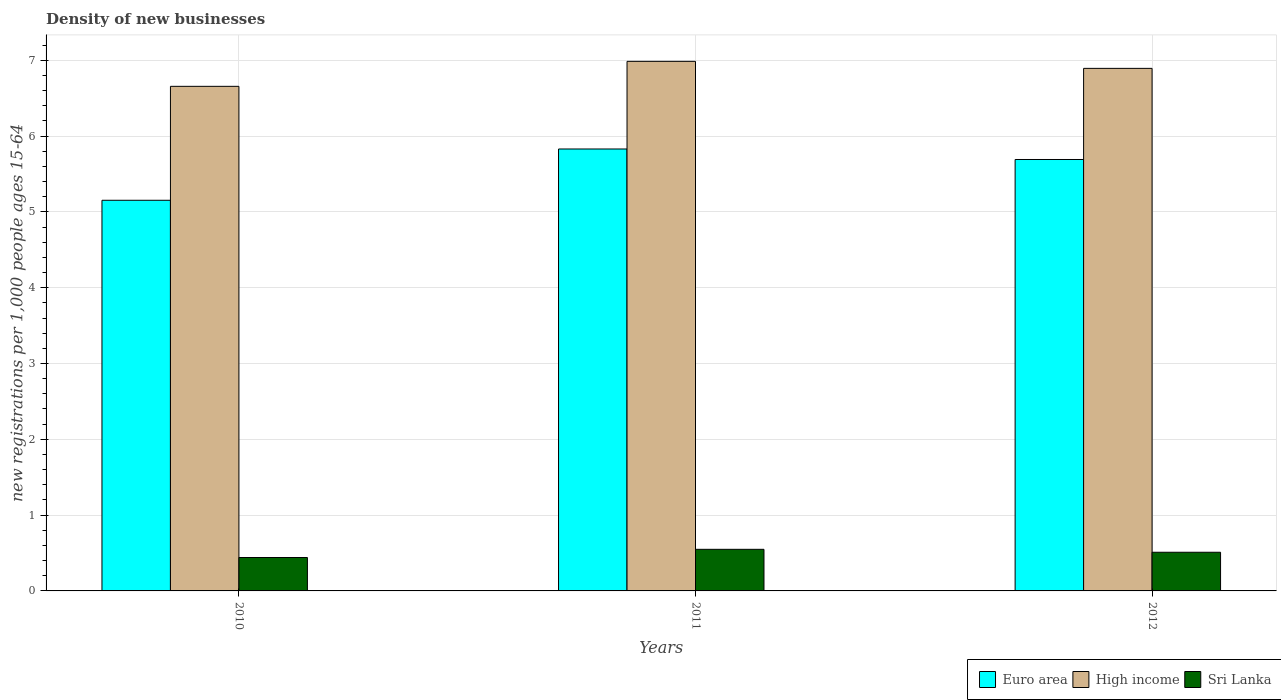Are the number of bars on each tick of the X-axis equal?
Offer a terse response. Yes. How many bars are there on the 2nd tick from the right?
Your answer should be very brief. 3. In how many cases, is the number of bars for a given year not equal to the number of legend labels?
Your answer should be very brief. 0. What is the number of new registrations in Sri Lanka in 2010?
Provide a succinct answer. 0.44. Across all years, what is the maximum number of new registrations in Sri Lanka?
Provide a short and direct response. 0.55. Across all years, what is the minimum number of new registrations in Sri Lanka?
Keep it short and to the point. 0.44. In which year was the number of new registrations in Euro area minimum?
Your answer should be very brief. 2010. What is the total number of new registrations in Sri Lanka in the graph?
Your response must be concise. 1.5. What is the difference between the number of new registrations in High income in 2010 and that in 2011?
Make the answer very short. -0.33. What is the difference between the number of new registrations in Sri Lanka in 2011 and the number of new registrations in Euro area in 2010?
Offer a very short reply. -4.6. What is the average number of new registrations in Euro area per year?
Make the answer very short. 5.56. In the year 2012, what is the difference between the number of new registrations in Sri Lanka and number of new registrations in Euro area?
Make the answer very short. -5.18. What is the ratio of the number of new registrations in High income in 2010 to that in 2011?
Give a very brief answer. 0.95. Is the difference between the number of new registrations in Sri Lanka in 2010 and 2011 greater than the difference between the number of new registrations in Euro area in 2010 and 2011?
Provide a succinct answer. Yes. What is the difference between the highest and the second highest number of new registrations in Sri Lanka?
Provide a succinct answer. 0.04. What is the difference between the highest and the lowest number of new registrations in High income?
Provide a succinct answer. 0.33. In how many years, is the number of new registrations in Euro area greater than the average number of new registrations in Euro area taken over all years?
Ensure brevity in your answer.  2. Is the sum of the number of new registrations in Sri Lanka in 2011 and 2012 greater than the maximum number of new registrations in Euro area across all years?
Offer a very short reply. No. What does the 3rd bar from the left in 2011 represents?
Provide a short and direct response. Sri Lanka. Is it the case that in every year, the sum of the number of new registrations in Euro area and number of new registrations in High income is greater than the number of new registrations in Sri Lanka?
Offer a terse response. Yes. How many bars are there?
Provide a short and direct response. 9. Are all the bars in the graph horizontal?
Offer a very short reply. No. How many years are there in the graph?
Offer a terse response. 3. What is the difference between two consecutive major ticks on the Y-axis?
Offer a very short reply. 1. Are the values on the major ticks of Y-axis written in scientific E-notation?
Offer a terse response. No. Does the graph contain grids?
Offer a terse response. Yes. Where does the legend appear in the graph?
Provide a short and direct response. Bottom right. What is the title of the graph?
Your answer should be compact. Density of new businesses. What is the label or title of the X-axis?
Your response must be concise. Years. What is the label or title of the Y-axis?
Give a very brief answer. New registrations per 1,0 people ages 15-64. What is the new registrations per 1,000 people ages 15-64 of Euro area in 2010?
Your response must be concise. 5.15. What is the new registrations per 1,000 people ages 15-64 in High income in 2010?
Keep it short and to the point. 6.66. What is the new registrations per 1,000 people ages 15-64 in Sri Lanka in 2010?
Give a very brief answer. 0.44. What is the new registrations per 1,000 people ages 15-64 in Euro area in 2011?
Provide a succinct answer. 5.83. What is the new registrations per 1,000 people ages 15-64 of High income in 2011?
Offer a terse response. 6.99. What is the new registrations per 1,000 people ages 15-64 of Sri Lanka in 2011?
Provide a succinct answer. 0.55. What is the new registrations per 1,000 people ages 15-64 of Euro area in 2012?
Provide a succinct answer. 5.69. What is the new registrations per 1,000 people ages 15-64 in High income in 2012?
Your answer should be compact. 6.89. What is the new registrations per 1,000 people ages 15-64 of Sri Lanka in 2012?
Make the answer very short. 0.51. Across all years, what is the maximum new registrations per 1,000 people ages 15-64 in Euro area?
Your answer should be compact. 5.83. Across all years, what is the maximum new registrations per 1,000 people ages 15-64 in High income?
Your response must be concise. 6.99. Across all years, what is the maximum new registrations per 1,000 people ages 15-64 in Sri Lanka?
Your response must be concise. 0.55. Across all years, what is the minimum new registrations per 1,000 people ages 15-64 in Euro area?
Your answer should be very brief. 5.15. Across all years, what is the minimum new registrations per 1,000 people ages 15-64 in High income?
Offer a very short reply. 6.66. Across all years, what is the minimum new registrations per 1,000 people ages 15-64 of Sri Lanka?
Make the answer very short. 0.44. What is the total new registrations per 1,000 people ages 15-64 of Euro area in the graph?
Offer a very short reply. 16.67. What is the total new registrations per 1,000 people ages 15-64 of High income in the graph?
Provide a short and direct response. 20.53. What is the total new registrations per 1,000 people ages 15-64 in Sri Lanka in the graph?
Offer a terse response. 1.5. What is the difference between the new registrations per 1,000 people ages 15-64 of Euro area in 2010 and that in 2011?
Offer a very short reply. -0.68. What is the difference between the new registrations per 1,000 people ages 15-64 in High income in 2010 and that in 2011?
Your answer should be compact. -0.33. What is the difference between the new registrations per 1,000 people ages 15-64 in Sri Lanka in 2010 and that in 2011?
Ensure brevity in your answer.  -0.11. What is the difference between the new registrations per 1,000 people ages 15-64 of Euro area in 2010 and that in 2012?
Your response must be concise. -0.54. What is the difference between the new registrations per 1,000 people ages 15-64 in High income in 2010 and that in 2012?
Your answer should be compact. -0.24. What is the difference between the new registrations per 1,000 people ages 15-64 of Sri Lanka in 2010 and that in 2012?
Offer a very short reply. -0.07. What is the difference between the new registrations per 1,000 people ages 15-64 of Euro area in 2011 and that in 2012?
Keep it short and to the point. 0.14. What is the difference between the new registrations per 1,000 people ages 15-64 of High income in 2011 and that in 2012?
Your response must be concise. 0.09. What is the difference between the new registrations per 1,000 people ages 15-64 of Sri Lanka in 2011 and that in 2012?
Your response must be concise. 0.04. What is the difference between the new registrations per 1,000 people ages 15-64 of Euro area in 2010 and the new registrations per 1,000 people ages 15-64 of High income in 2011?
Offer a very short reply. -1.83. What is the difference between the new registrations per 1,000 people ages 15-64 of Euro area in 2010 and the new registrations per 1,000 people ages 15-64 of Sri Lanka in 2011?
Offer a very short reply. 4.6. What is the difference between the new registrations per 1,000 people ages 15-64 of High income in 2010 and the new registrations per 1,000 people ages 15-64 of Sri Lanka in 2011?
Your answer should be very brief. 6.11. What is the difference between the new registrations per 1,000 people ages 15-64 in Euro area in 2010 and the new registrations per 1,000 people ages 15-64 in High income in 2012?
Make the answer very short. -1.74. What is the difference between the new registrations per 1,000 people ages 15-64 in Euro area in 2010 and the new registrations per 1,000 people ages 15-64 in Sri Lanka in 2012?
Keep it short and to the point. 4.64. What is the difference between the new registrations per 1,000 people ages 15-64 in High income in 2010 and the new registrations per 1,000 people ages 15-64 in Sri Lanka in 2012?
Your answer should be very brief. 6.15. What is the difference between the new registrations per 1,000 people ages 15-64 of Euro area in 2011 and the new registrations per 1,000 people ages 15-64 of High income in 2012?
Provide a succinct answer. -1.06. What is the difference between the new registrations per 1,000 people ages 15-64 in Euro area in 2011 and the new registrations per 1,000 people ages 15-64 in Sri Lanka in 2012?
Make the answer very short. 5.32. What is the difference between the new registrations per 1,000 people ages 15-64 of High income in 2011 and the new registrations per 1,000 people ages 15-64 of Sri Lanka in 2012?
Keep it short and to the point. 6.48. What is the average new registrations per 1,000 people ages 15-64 of Euro area per year?
Your response must be concise. 5.56. What is the average new registrations per 1,000 people ages 15-64 of High income per year?
Give a very brief answer. 6.84. What is the average new registrations per 1,000 people ages 15-64 in Sri Lanka per year?
Your response must be concise. 0.5. In the year 2010, what is the difference between the new registrations per 1,000 people ages 15-64 of Euro area and new registrations per 1,000 people ages 15-64 of High income?
Your answer should be very brief. -1.5. In the year 2010, what is the difference between the new registrations per 1,000 people ages 15-64 of Euro area and new registrations per 1,000 people ages 15-64 of Sri Lanka?
Offer a terse response. 4.71. In the year 2010, what is the difference between the new registrations per 1,000 people ages 15-64 of High income and new registrations per 1,000 people ages 15-64 of Sri Lanka?
Keep it short and to the point. 6.22. In the year 2011, what is the difference between the new registrations per 1,000 people ages 15-64 in Euro area and new registrations per 1,000 people ages 15-64 in High income?
Your answer should be compact. -1.16. In the year 2011, what is the difference between the new registrations per 1,000 people ages 15-64 in Euro area and new registrations per 1,000 people ages 15-64 in Sri Lanka?
Offer a terse response. 5.28. In the year 2011, what is the difference between the new registrations per 1,000 people ages 15-64 of High income and new registrations per 1,000 people ages 15-64 of Sri Lanka?
Offer a terse response. 6.44. In the year 2012, what is the difference between the new registrations per 1,000 people ages 15-64 of Euro area and new registrations per 1,000 people ages 15-64 of High income?
Provide a succinct answer. -1.2. In the year 2012, what is the difference between the new registrations per 1,000 people ages 15-64 of Euro area and new registrations per 1,000 people ages 15-64 of Sri Lanka?
Your response must be concise. 5.18. In the year 2012, what is the difference between the new registrations per 1,000 people ages 15-64 in High income and new registrations per 1,000 people ages 15-64 in Sri Lanka?
Ensure brevity in your answer.  6.38. What is the ratio of the new registrations per 1,000 people ages 15-64 of Euro area in 2010 to that in 2011?
Offer a very short reply. 0.88. What is the ratio of the new registrations per 1,000 people ages 15-64 in High income in 2010 to that in 2011?
Provide a short and direct response. 0.95. What is the ratio of the new registrations per 1,000 people ages 15-64 of Sri Lanka in 2010 to that in 2011?
Keep it short and to the point. 0.8. What is the ratio of the new registrations per 1,000 people ages 15-64 of Euro area in 2010 to that in 2012?
Offer a very short reply. 0.91. What is the ratio of the new registrations per 1,000 people ages 15-64 in High income in 2010 to that in 2012?
Offer a terse response. 0.97. What is the ratio of the new registrations per 1,000 people ages 15-64 in Sri Lanka in 2010 to that in 2012?
Provide a succinct answer. 0.86. What is the ratio of the new registrations per 1,000 people ages 15-64 in Euro area in 2011 to that in 2012?
Make the answer very short. 1.02. What is the ratio of the new registrations per 1,000 people ages 15-64 in High income in 2011 to that in 2012?
Offer a terse response. 1.01. What is the ratio of the new registrations per 1,000 people ages 15-64 in Sri Lanka in 2011 to that in 2012?
Offer a very short reply. 1.08. What is the difference between the highest and the second highest new registrations per 1,000 people ages 15-64 in Euro area?
Make the answer very short. 0.14. What is the difference between the highest and the second highest new registrations per 1,000 people ages 15-64 of High income?
Your response must be concise. 0.09. What is the difference between the highest and the second highest new registrations per 1,000 people ages 15-64 of Sri Lanka?
Keep it short and to the point. 0.04. What is the difference between the highest and the lowest new registrations per 1,000 people ages 15-64 of Euro area?
Give a very brief answer. 0.68. What is the difference between the highest and the lowest new registrations per 1,000 people ages 15-64 of High income?
Your answer should be very brief. 0.33. What is the difference between the highest and the lowest new registrations per 1,000 people ages 15-64 of Sri Lanka?
Your response must be concise. 0.11. 